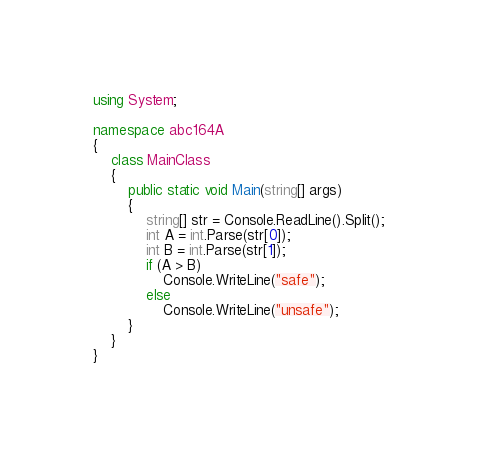<code> <loc_0><loc_0><loc_500><loc_500><_C#_>using System;

namespace abc164A
{
    class MainClass
    {
        public static void Main(string[] args)
        {
            string[] str = Console.ReadLine().Split();
            int A = int.Parse(str[0]);
            int B = int.Parse(str[1]);
            if (A > B)
                Console.WriteLine("safe");
            else
                Console.WriteLine("unsafe");
        }
    }
}
</code> 